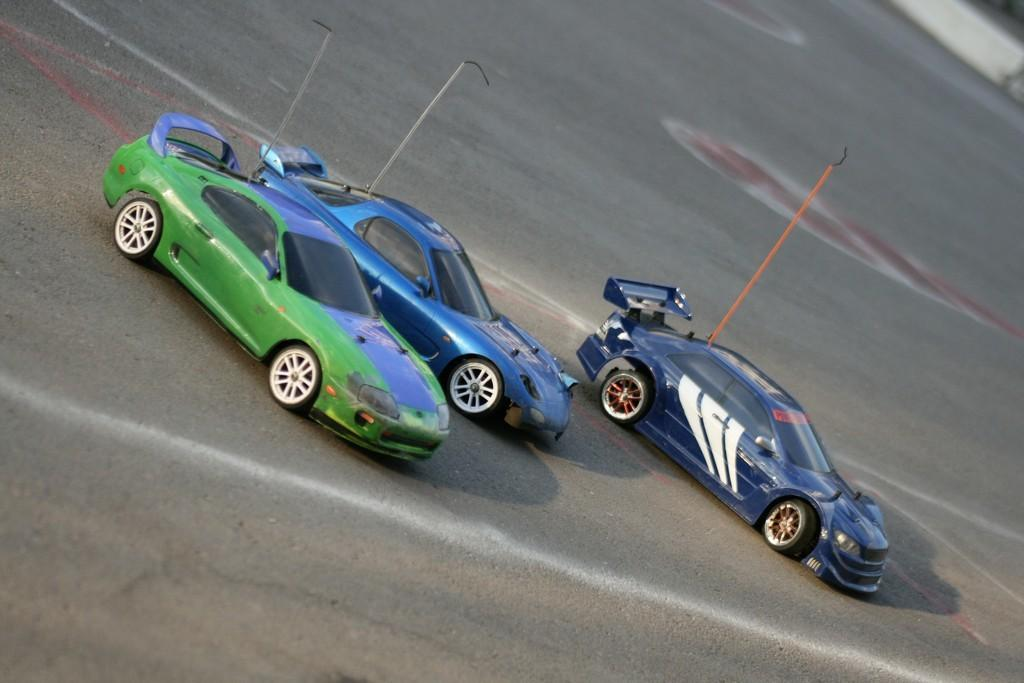What type of vehicles are in the image? There are three racing cars in the image. Where are the racing cars located? The racing cars are parked on the road. What type of lizards can be seen crawling on the racing cars in the image? There are no lizards present in the image; it only features racing cars parked on the road. 